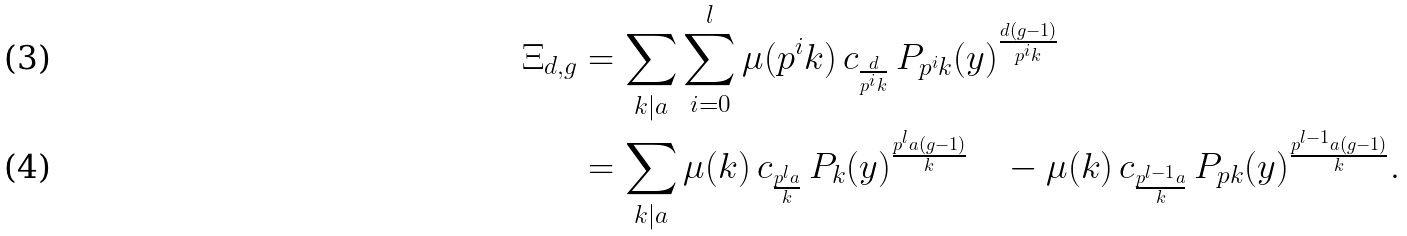<formula> <loc_0><loc_0><loc_500><loc_500>\Xi _ { d , g } & = \sum _ { k | a } \sum _ { i = 0 } ^ { l } \mu ( p ^ { i } k ) \, c _ { \frac { d } { p ^ { i } k } } \, P _ { p ^ { i } k } ( y ) ^ { \frac { d ( g - 1 ) } { p ^ { i } k } } \\ & = \sum _ { k | a } \mu ( { k } ) \, c _ { \frac { p ^ { l } a } { k } } \, P _ { k } ( y ) ^ { \frac { p ^ { l } a ( g - 1 ) } { k } } \quad - \mu ( { k } ) \, c _ { \frac { p ^ { l - 1 } a } { k } } \, P _ { p { k } } ( y ) ^ { \frac { p ^ { l - 1 } a ( g - 1 ) } { k } } .</formula> 